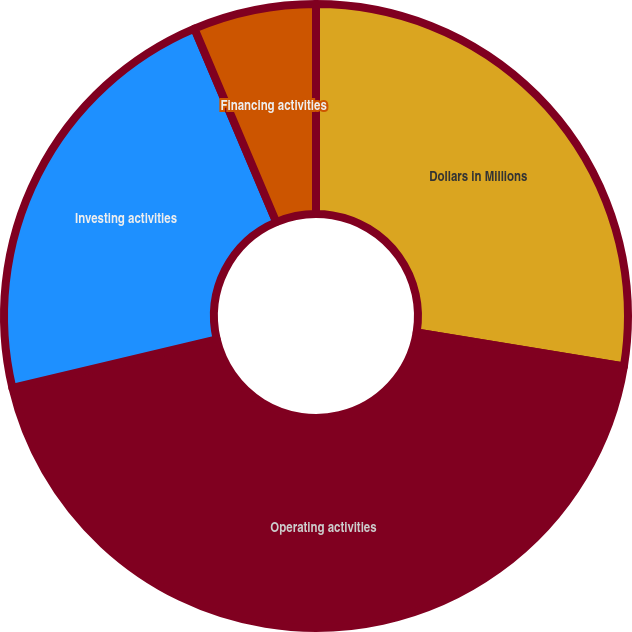Convert chart. <chart><loc_0><loc_0><loc_500><loc_500><pie_chart><fcel>Dollars in Millions<fcel>Operating activities<fcel>Investing activities<fcel>Financing activities<nl><fcel>27.58%<fcel>43.72%<fcel>22.33%<fcel>6.37%<nl></chart> 